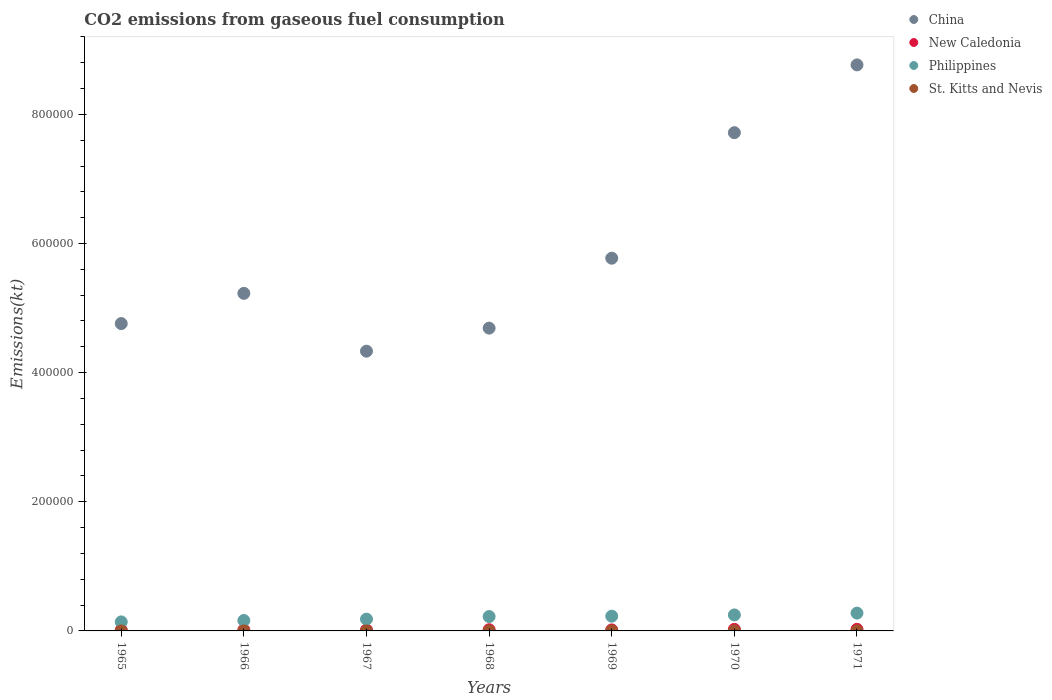Is the number of dotlines equal to the number of legend labels?
Your answer should be compact. Yes. What is the amount of CO2 emitted in China in 1970?
Ensure brevity in your answer.  7.72e+05. Across all years, what is the maximum amount of CO2 emitted in New Caledonia?
Give a very brief answer. 2420.22. Across all years, what is the minimum amount of CO2 emitted in China?
Provide a short and direct response. 4.33e+05. In which year was the amount of CO2 emitted in Philippines maximum?
Your answer should be very brief. 1971. In which year was the amount of CO2 emitted in New Caledonia minimum?
Offer a very short reply. 1965. What is the total amount of CO2 emitted in Philippines in the graph?
Ensure brevity in your answer.  1.46e+05. What is the difference between the amount of CO2 emitted in China in 1966 and that in 1969?
Give a very brief answer. -5.44e+04. What is the difference between the amount of CO2 emitted in China in 1971 and the amount of CO2 emitted in St. Kitts and Nevis in 1970?
Ensure brevity in your answer.  8.77e+05. What is the average amount of CO2 emitted in St. Kitts and Nevis per year?
Offer a terse response. 25.67. In the year 1966, what is the difference between the amount of CO2 emitted in St. Kitts and Nevis and amount of CO2 emitted in New Caledonia?
Give a very brief answer. -1488.8. In how many years, is the amount of CO2 emitted in New Caledonia greater than 640000 kt?
Your answer should be compact. 0. What is the ratio of the amount of CO2 emitted in New Caledonia in 1965 to that in 1969?
Your answer should be very brief. 0.79. What is the difference between the highest and the second highest amount of CO2 emitted in China?
Your answer should be very brief. 1.05e+05. What is the difference between the highest and the lowest amount of CO2 emitted in St. Kitts and Nevis?
Ensure brevity in your answer.  11. Is it the case that in every year, the sum of the amount of CO2 emitted in St. Kitts and Nevis and amount of CO2 emitted in Philippines  is greater than the amount of CO2 emitted in China?
Your answer should be very brief. No. Does the amount of CO2 emitted in New Caledonia monotonically increase over the years?
Make the answer very short. No. Is the amount of CO2 emitted in China strictly greater than the amount of CO2 emitted in Philippines over the years?
Provide a short and direct response. Yes. How many dotlines are there?
Your answer should be compact. 4. How many years are there in the graph?
Your response must be concise. 7. What is the difference between two consecutive major ticks on the Y-axis?
Your response must be concise. 2.00e+05. Are the values on the major ticks of Y-axis written in scientific E-notation?
Offer a terse response. No. Does the graph contain grids?
Keep it short and to the point. No. How many legend labels are there?
Provide a short and direct response. 4. How are the legend labels stacked?
Keep it short and to the point. Vertical. What is the title of the graph?
Your response must be concise. CO2 emissions from gaseous fuel consumption. What is the label or title of the Y-axis?
Ensure brevity in your answer.  Emissions(kt). What is the Emissions(kt) of China in 1965?
Your response must be concise. 4.76e+05. What is the Emissions(kt) of New Caledonia in 1965?
Your answer should be compact. 1232.11. What is the Emissions(kt) of Philippines in 1965?
Give a very brief answer. 1.40e+04. What is the Emissions(kt) of St. Kitts and Nevis in 1965?
Ensure brevity in your answer.  22. What is the Emissions(kt) of China in 1966?
Ensure brevity in your answer.  5.23e+05. What is the Emissions(kt) in New Caledonia in 1966?
Make the answer very short. 1510.8. What is the Emissions(kt) in Philippines in 1966?
Make the answer very short. 1.61e+04. What is the Emissions(kt) in St. Kitts and Nevis in 1966?
Offer a terse response. 22. What is the Emissions(kt) of China in 1967?
Offer a very short reply. 4.33e+05. What is the Emissions(kt) in New Caledonia in 1967?
Keep it short and to the point. 1474.13. What is the Emissions(kt) of Philippines in 1967?
Your answer should be compact. 1.82e+04. What is the Emissions(kt) in St. Kitts and Nevis in 1967?
Provide a short and direct response. 22. What is the Emissions(kt) of China in 1968?
Provide a succinct answer. 4.69e+05. What is the Emissions(kt) of New Caledonia in 1968?
Your answer should be very brief. 1840.83. What is the Emissions(kt) of Philippines in 1968?
Ensure brevity in your answer.  2.23e+04. What is the Emissions(kt) of St. Kitts and Nevis in 1968?
Ensure brevity in your answer.  33. What is the Emissions(kt) in China in 1969?
Make the answer very short. 5.77e+05. What is the Emissions(kt) in New Caledonia in 1969?
Keep it short and to the point. 1558.47. What is the Emissions(kt) of Philippines in 1969?
Ensure brevity in your answer.  2.29e+04. What is the Emissions(kt) in St. Kitts and Nevis in 1969?
Provide a succinct answer. 25.67. What is the Emissions(kt) of China in 1970?
Your answer should be compact. 7.72e+05. What is the Emissions(kt) of New Caledonia in 1970?
Your response must be concise. 2394.55. What is the Emissions(kt) in Philippines in 1970?
Give a very brief answer. 2.48e+04. What is the Emissions(kt) of St. Kitts and Nevis in 1970?
Your answer should be compact. 25.67. What is the Emissions(kt) in China in 1971?
Ensure brevity in your answer.  8.77e+05. What is the Emissions(kt) of New Caledonia in 1971?
Keep it short and to the point. 2420.22. What is the Emissions(kt) in Philippines in 1971?
Your response must be concise. 2.76e+04. What is the Emissions(kt) of St. Kitts and Nevis in 1971?
Your answer should be very brief. 29.34. Across all years, what is the maximum Emissions(kt) in China?
Give a very brief answer. 8.77e+05. Across all years, what is the maximum Emissions(kt) of New Caledonia?
Provide a short and direct response. 2420.22. Across all years, what is the maximum Emissions(kt) in Philippines?
Keep it short and to the point. 2.76e+04. Across all years, what is the maximum Emissions(kt) of St. Kitts and Nevis?
Provide a succinct answer. 33. Across all years, what is the minimum Emissions(kt) of China?
Your response must be concise. 4.33e+05. Across all years, what is the minimum Emissions(kt) in New Caledonia?
Offer a very short reply. 1232.11. Across all years, what is the minimum Emissions(kt) in Philippines?
Your answer should be very brief. 1.40e+04. Across all years, what is the minimum Emissions(kt) in St. Kitts and Nevis?
Give a very brief answer. 22. What is the total Emissions(kt) in China in the graph?
Provide a short and direct response. 4.13e+06. What is the total Emissions(kt) in New Caledonia in the graph?
Your answer should be very brief. 1.24e+04. What is the total Emissions(kt) in Philippines in the graph?
Provide a short and direct response. 1.46e+05. What is the total Emissions(kt) of St. Kitts and Nevis in the graph?
Provide a short and direct response. 179.68. What is the difference between the Emissions(kt) of China in 1965 and that in 1966?
Make the answer very short. -4.68e+04. What is the difference between the Emissions(kt) of New Caledonia in 1965 and that in 1966?
Give a very brief answer. -278.69. What is the difference between the Emissions(kt) of Philippines in 1965 and that in 1966?
Give a very brief answer. -2141.53. What is the difference between the Emissions(kt) of St. Kitts and Nevis in 1965 and that in 1966?
Your response must be concise. 0. What is the difference between the Emissions(kt) of China in 1965 and that in 1967?
Give a very brief answer. 4.27e+04. What is the difference between the Emissions(kt) of New Caledonia in 1965 and that in 1967?
Offer a terse response. -242.02. What is the difference between the Emissions(kt) of Philippines in 1965 and that in 1967?
Your response must be concise. -4250.05. What is the difference between the Emissions(kt) of St. Kitts and Nevis in 1965 and that in 1967?
Provide a short and direct response. 0. What is the difference between the Emissions(kt) in China in 1965 and that in 1968?
Offer a terse response. 7044.31. What is the difference between the Emissions(kt) of New Caledonia in 1965 and that in 1968?
Your answer should be very brief. -608.72. What is the difference between the Emissions(kt) in Philippines in 1965 and that in 1968?
Your answer should be very brief. -8269.08. What is the difference between the Emissions(kt) in St. Kitts and Nevis in 1965 and that in 1968?
Ensure brevity in your answer.  -11. What is the difference between the Emissions(kt) in China in 1965 and that in 1969?
Provide a short and direct response. -1.01e+05. What is the difference between the Emissions(kt) in New Caledonia in 1965 and that in 1969?
Provide a succinct answer. -326.36. What is the difference between the Emissions(kt) of Philippines in 1965 and that in 1969?
Ensure brevity in your answer.  -8877.81. What is the difference between the Emissions(kt) of St. Kitts and Nevis in 1965 and that in 1969?
Offer a very short reply. -3.67. What is the difference between the Emissions(kt) in China in 1965 and that in 1970?
Give a very brief answer. -2.96e+05. What is the difference between the Emissions(kt) of New Caledonia in 1965 and that in 1970?
Keep it short and to the point. -1162.44. What is the difference between the Emissions(kt) in Philippines in 1965 and that in 1970?
Offer a very short reply. -1.08e+04. What is the difference between the Emissions(kt) of St. Kitts and Nevis in 1965 and that in 1970?
Offer a very short reply. -3.67. What is the difference between the Emissions(kt) in China in 1965 and that in 1971?
Make the answer very short. -4.01e+05. What is the difference between the Emissions(kt) in New Caledonia in 1965 and that in 1971?
Your response must be concise. -1188.11. What is the difference between the Emissions(kt) in Philippines in 1965 and that in 1971?
Give a very brief answer. -1.36e+04. What is the difference between the Emissions(kt) in St. Kitts and Nevis in 1965 and that in 1971?
Your response must be concise. -7.33. What is the difference between the Emissions(kt) of China in 1966 and that in 1967?
Offer a terse response. 8.96e+04. What is the difference between the Emissions(kt) of New Caledonia in 1966 and that in 1967?
Give a very brief answer. 36.67. What is the difference between the Emissions(kt) in Philippines in 1966 and that in 1967?
Provide a short and direct response. -2108.53. What is the difference between the Emissions(kt) of China in 1966 and that in 1968?
Offer a terse response. 5.39e+04. What is the difference between the Emissions(kt) of New Caledonia in 1966 and that in 1968?
Provide a succinct answer. -330.03. What is the difference between the Emissions(kt) of Philippines in 1966 and that in 1968?
Offer a very short reply. -6127.56. What is the difference between the Emissions(kt) of St. Kitts and Nevis in 1966 and that in 1968?
Your answer should be compact. -11. What is the difference between the Emissions(kt) in China in 1966 and that in 1969?
Provide a succinct answer. -5.44e+04. What is the difference between the Emissions(kt) in New Caledonia in 1966 and that in 1969?
Keep it short and to the point. -47.67. What is the difference between the Emissions(kt) in Philippines in 1966 and that in 1969?
Provide a short and direct response. -6736.28. What is the difference between the Emissions(kt) of St. Kitts and Nevis in 1966 and that in 1969?
Make the answer very short. -3.67. What is the difference between the Emissions(kt) in China in 1966 and that in 1970?
Provide a succinct answer. -2.49e+05. What is the difference between the Emissions(kt) of New Caledonia in 1966 and that in 1970?
Ensure brevity in your answer.  -883.75. What is the difference between the Emissions(kt) in Philippines in 1966 and that in 1970?
Give a very brief answer. -8657.79. What is the difference between the Emissions(kt) in St. Kitts and Nevis in 1966 and that in 1970?
Keep it short and to the point. -3.67. What is the difference between the Emissions(kt) in China in 1966 and that in 1971?
Your answer should be compact. -3.54e+05. What is the difference between the Emissions(kt) in New Caledonia in 1966 and that in 1971?
Your answer should be very brief. -909.42. What is the difference between the Emissions(kt) of Philippines in 1966 and that in 1971?
Your answer should be compact. -1.15e+04. What is the difference between the Emissions(kt) in St. Kitts and Nevis in 1966 and that in 1971?
Your answer should be very brief. -7.33. What is the difference between the Emissions(kt) of China in 1967 and that in 1968?
Ensure brevity in your answer.  -3.57e+04. What is the difference between the Emissions(kt) in New Caledonia in 1967 and that in 1968?
Offer a very short reply. -366.7. What is the difference between the Emissions(kt) of Philippines in 1967 and that in 1968?
Your response must be concise. -4019.03. What is the difference between the Emissions(kt) in St. Kitts and Nevis in 1967 and that in 1968?
Provide a succinct answer. -11. What is the difference between the Emissions(kt) of China in 1967 and that in 1969?
Give a very brief answer. -1.44e+05. What is the difference between the Emissions(kt) of New Caledonia in 1967 and that in 1969?
Give a very brief answer. -84.34. What is the difference between the Emissions(kt) in Philippines in 1967 and that in 1969?
Make the answer very short. -4627.75. What is the difference between the Emissions(kt) in St. Kitts and Nevis in 1967 and that in 1969?
Give a very brief answer. -3.67. What is the difference between the Emissions(kt) in China in 1967 and that in 1970?
Make the answer very short. -3.38e+05. What is the difference between the Emissions(kt) of New Caledonia in 1967 and that in 1970?
Provide a short and direct response. -920.42. What is the difference between the Emissions(kt) in Philippines in 1967 and that in 1970?
Ensure brevity in your answer.  -6549.26. What is the difference between the Emissions(kt) of St. Kitts and Nevis in 1967 and that in 1970?
Provide a short and direct response. -3.67. What is the difference between the Emissions(kt) of China in 1967 and that in 1971?
Ensure brevity in your answer.  -4.43e+05. What is the difference between the Emissions(kt) in New Caledonia in 1967 and that in 1971?
Your answer should be compact. -946.09. What is the difference between the Emissions(kt) of Philippines in 1967 and that in 1971?
Provide a short and direct response. -9354.52. What is the difference between the Emissions(kt) in St. Kitts and Nevis in 1967 and that in 1971?
Your answer should be compact. -7.33. What is the difference between the Emissions(kt) in China in 1968 and that in 1969?
Offer a very short reply. -1.08e+05. What is the difference between the Emissions(kt) of New Caledonia in 1968 and that in 1969?
Provide a short and direct response. 282.36. What is the difference between the Emissions(kt) in Philippines in 1968 and that in 1969?
Make the answer very short. -608.72. What is the difference between the Emissions(kt) of St. Kitts and Nevis in 1968 and that in 1969?
Your answer should be compact. 7.33. What is the difference between the Emissions(kt) in China in 1968 and that in 1970?
Provide a succinct answer. -3.03e+05. What is the difference between the Emissions(kt) in New Caledonia in 1968 and that in 1970?
Offer a very short reply. -553.72. What is the difference between the Emissions(kt) of Philippines in 1968 and that in 1970?
Give a very brief answer. -2530.23. What is the difference between the Emissions(kt) in St. Kitts and Nevis in 1968 and that in 1970?
Ensure brevity in your answer.  7.33. What is the difference between the Emissions(kt) of China in 1968 and that in 1971?
Keep it short and to the point. -4.08e+05. What is the difference between the Emissions(kt) of New Caledonia in 1968 and that in 1971?
Ensure brevity in your answer.  -579.39. What is the difference between the Emissions(kt) of Philippines in 1968 and that in 1971?
Give a very brief answer. -5335.48. What is the difference between the Emissions(kt) of St. Kitts and Nevis in 1968 and that in 1971?
Provide a succinct answer. 3.67. What is the difference between the Emissions(kt) of China in 1969 and that in 1970?
Give a very brief answer. -1.94e+05. What is the difference between the Emissions(kt) in New Caledonia in 1969 and that in 1970?
Your answer should be very brief. -836.08. What is the difference between the Emissions(kt) in Philippines in 1969 and that in 1970?
Your answer should be very brief. -1921.51. What is the difference between the Emissions(kt) in St. Kitts and Nevis in 1969 and that in 1970?
Your answer should be very brief. 0. What is the difference between the Emissions(kt) in China in 1969 and that in 1971?
Offer a very short reply. -2.99e+05. What is the difference between the Emissions(kt) in New Caledonia in 1969 and that in 1971?
Your answer should be compact. -861.75. What is the difference between the Emissions(kt) of Philippines in 1969 and that in 1971?
Keep it short and to the point. -4726.76. What is the difference between the Emissions(kt) in St. Kitts and Nevis in 1969 and that in 1971?
Provide a short and direct response. -3.67. What is the difference between the Emissions(kt) in China in 1970 and that in 1971?
Offer a very short reply. -1.05e+05. What is the difference between the Emissions(kt) of New Caledonia in 1970 and that in 1971?
Provide a succinct answer. -25.67. What is the difference between the Emissions(kt) of Philippines in 1970 and that in 1971?
Provide a short and direct response. -2805.26. What is the difference between the Emissions(kt) of St. Kitts and Nevis in 1970 and that in 1971?
Make the answer very short. -3.67. What is the difference between the Emissions(kt) in China in 1965 and the Emissions(kt) in New Caledonia in 1966?
Ensure brevity in your answer.  4.74e+05. What is the difference between the Emissions(kt) of China in 1965 and the Emissions(kt) of Philippines in 1966?
Your answer should be compact. 4.60e+05. What is the difference between the Emissions(kt) in China in 1965 and the Emissions(kt) in St. Kitts and Nevis in 1966?
Provide a short and direct response. 4.76e+05. What is the difference between the Emissions(kt) of New Caledonia in 1965 and the Emissions(kt) of Philippines in 1966?
Your response must be concise. -1.49e+04. What is the difference between the Emissions(kt) in New Caledonia in 1965 and the Emissions(kt) in St. Kitts and Nevis in 1966?
Ensure brevity in your answer.  1210.11. What is the difference between the Emissions(kt) in Philippines in 1965 and the Emissions(kt) in St. Kitts and Nevis in 1966?
Give a very brief answer. 1.40e+04. What is the difference between the Emissions(kt) of China in 1965 and the Emissions(kt) of New Caledonia in 1967?
Your answer should be compact. 4.74e+05. What is the difference between the Emissions(kt) in China in 1965 and the Emissions(kt) in Philippines in 1967?
Give a very brief answer. 4.58e+05. What is the difference between the Emissions(kt) of China in 1965 and the Emissions(kt) of St. Kitts and Nevis in 1967?
Your response must be concise. 4.76e+05. What is the difference between the Emissions(kt) of New Caledonia in 1965 and the Emissions(kt) of Philippines in 1967?
Your answer should be compact. -1.70e+04. What is the difference between the Emissions(kt) of New Caledonia in 1965 and the Emissions(kt) of St. Kitts and Nevis in 1967?
Offer a terse response. 1210.11. What is the difference between the Emissions(kt) of Philippines in 1965 and the Emissions(kt) of St. Kitts and Nevis in 1967?
Offer a terse response. 1.40e+04. What is the difference between the Emissions(kt) in China in 1965 and the Emissions(kt) in New Caledonia in 1968?
Make the answer very short. 4.74e+05. What is the difference between the Emissions(kt) of China in 1965 and the Emissions(kt) of Philippines in 1968?
Your answer should be compact. 4.54e+05. What is the difference between the Emissions(kt) in China in 1965 and the Emissions(kt) in St. Kitts and Nevis in 1968?
Your response must be concise. 4.76e+05. What is the difference between the Emissions(kt) of New Caledonia in 1965 and the Emissions(kt) of Philippines in 1968?
Offer a terse response. -2.10e+04. What is the difference between the Emissions(kt) in New Caledonia in 1965 and the Emissions(kt) in St. Kitts and Nevis in 1968?
Offer a very short reply. 1199.11. What is the difference between the Emissions(kt) in Philippines in 1965 and the Emissions(kt) in St. Kitts and Nevis in 1968?
Offer a terse response. 1.39e+04. What is the difference between the Emissions(kt) in China in 1965 and the Emissions(kt) in New Caledonia in 1969?
Your answer should be very brief. 4.74e+05. What is the difference between the Emissions(kt) of China in 1965 and the Emissions(kt) of Philippines in 1969?
Your response must be concise. 4.53e+05. What is the difference between the Emissions(kt) of China in 1965 and the Emissions(kt) of St. Kitts and Nevis in 1969?
Offer a terse response. 4.76e+05. What is the difference between the Emissions(kt) of New Caledonia in 1965 and the Emissions(kt) of Philippines in 1969?
Your answer should be very brief. -2.16e+04. What is the difference between the Emissions(kt) of New Caledonia in 1965 and the Emissions(kt) of St. Kitts and Nevis in 1969?
Provide a short and direct response. 1206.44. What is the difference between the Emissions(kt) of Philippines in 1965 and the Emissions(kt) of St. Kitts and Nevis in 1969?
Your response must be concise. 1.40e+04. What is the difference between the Emissions(kt) in China in 1965 and the Emissions(kt) in New Caledonia in 1970?
Give a very brief answer. 4.74e+05. What is the difference between the Emissions(kt) of China in 1965 and the Emissions(kt) of Philippines in 1970?
Make the answer very short. 4.51e+05. What is the difference between the Emissions(kt) of China in 1965 and the Emissions(kt) of St. Kitts and Nevis in 1970?
Your response must be concise. 4.76e+05. What is the difference between the Emissions(kt) in New Caledonia in 1965 and the Emissions(kt) in Philippines in 1970?
Make the answer very short. -2.35e+04. What is the difference between the Emissions(kt) of New Caledonia in 1965 and the Emissions(kt) of St. Kitts and Nevis in 1970?
Your answer should be very brief. 1206.44. What is the difference between the Emissions(kt) of Philippines in 1965 and the Emissions(kt) of St. Kitts and Nevis in 1970?
Your response must be concise. 1.40e+04. What is the difference between the Emissions(kt) of China in 1965 and the Emissions(kt) of New Caledonia in 1971?
Your response must be concise. 4.74e+05. What is the difference between the Emissions(kt) in China in 1965 and the Emissions(kt) in Philippines in 1971?
Ensure brevity in your answer.  4.48e+05. What is the difference between the Emissions(kt) in China in 1965 and the Emissions(kt) in St. Kitts and Nevis in 1971?
Provide a succinct answer. 4.76e+05. What is the difference between the Emissions(kt) of New Caledonia in 1965 and the Emissions(kt) of Philippines in 1971?
Your response must be concise. -2.64e+04. What is the difference between the Emissions(kt) in New Caledonia in 1965 and the Emissions(kt) in St. Kitts and Nevis in 1971?
Keep it short and to the point. 1202.78. What is the difference between the Emissions(kt) in Philippines in 1965 and the Emissions(kt) in St. Kitts and Nevis in 1971?
Ensure brevity in your answer.  1.40e+04. What is the difference between the Emissions(kt) in China in 1966 and the Emissions(kt) in New Caledonia in 1967?
Your answer should be compact. 5.21e+05. What is the difference between the Emissions(kt) in China in 1966 and the Emissions(kt) in Philippines in 1967?
Ensure brevity in your answer.  5.05e+05. What is the difference between the Emissions(kt) of China in 1966 and the Emissions(kt) of St. Kitts and Nevis in 1967?
Your answer should be compact. 5.23e+05. What is the difference between the Emissions(kt) in New Caledonia in 1966 and the Emissions(kt) in Philippines in 1967?
Make the answer very short. -1.67e+04. What is the difference between the Emissions(kt) of New Caledonia in 1966 and the Emissions(kt) of St. Kitts and Nevis in 1967?
Offer a terse response. 1488.8. What is the difference between the Emissions(kt) in Philippines in 1966 and the Emissions(kt) in St. Kitts and Nevis in 1967?
Your response must be concise. 1.61e+04. What is the difference between the Emissions(kt) of China in 1966 and the Emissions(kt) of New Caledonia in 1968?
Make the answer very short. 5.21e+05. What is the difference between the Emissions(kt) of China in 1966 and the Emissions(kt) of Philippines in 1968?
Provide a short and direct response. 5.01e+05. What is the difference between the Emissions(kt) in China in 1966 and the Emissions(kt) in St. Kitts and Nevis in 1968?
Offer a very short reply. 5.23e+05. What is the difference between the Emissions(kt) in New Caledonia in 1966 and the Emissions(kt) in Philippines in 1968?
Your answer should be compact. -2.07e+04. What is the difference between the Emissions(kt) of New Caledonia in 1966 and the Emissions(kt) of St. Kitts and Nevis in 1968?
Your response must be concise. 1477.8. What is the difference between the Emissions(kt) of Philippines in 1966 and the Emissions(kt) of St. Kitts and Nevis in 1968?
Give a very brief answer. 1.61e+04. What is the difference between the Emissions(kt) of China in 1966 and the Emissions(kt) of New Caledonia in 1969?
Provide a succinct answer. 5.21e+05. What is the difference between the Emissions(kt) in China in 1966 and the Emissions(kt) in Philippines in 1969?
Offer a very short reply. 5.00e+05. What is the difference between the Emissions(kt) in China in 1966 and the Emissions(kt) in St. Kitts and Nevis in 1969?
Offer a very short reply. 5.23e+05. What is the difference between the Emissions(kt) in New Caledonia in 1966 and the Emissions(kt) in Philippines in 1969?
Offer a terse response. -2.13e+04. What is the difference between the Emissions(kt) in New Caledonia in 1966 and the Emissions(kt) in St. Kitts and Nevis in 1969?
Provide a short and direct response. 1485.13. What is the difference between the Emissions(kt) of Philippines in 1966 and the Emissions(kt) of St. Kitts and Nevis in 1969?
Your answer should be compact. 1.61e+04. What is the difference between the Emissions(kt) of China in 1966 and the Emissions(kt) of New Caledonia in 1970?
Ensure brevity in your answer.  5.20e+05. What is the difference between the Emissions(kt) in China in 1966 and the Emissions(kt) in Philippines in 1970?
Ensure brevity in your answer.  4.98e+05. What is the difference between the Emissions(kt) in China in 1966 and the Emissions(kt) in St. Kitts and Nevis in 1970?
Provide a succinct answer. 5.23e+05. What is the difference between the Emissions(kt) of New Caledonia in 1966 and the Emissions(kt) of Philippines in 1970?
Give a very brief answer. -2.33e+04. What is the difference between the Emissions(kt) in New Caledonia in 1966 and the Emissions(kt) in St. Kitts and Nevis in 1970?
Your answer should be very brief. 1485.13. What is the difference between the Emissions(kt) in Philippines in 1966 and the Emissions(kt) in St. Kitts and Nevis in 1970?
Offer a terse response. 1.61e+04. What is the difference between the Emissions(kt) in China in 1966 and the Emissions(kt) in New Caledonia in 1971?
Keep it short and to the point. 5.20e+05. What is the difference between the Emissions(kt) in China in 1966 and the Emissions(kt) in Philippines in 1971?
Give a very brief answer. 4.95e+05. What is the difference between the Emissions(kt) of China in 1966 and the Emissions(kt) of St. Kitts and Nevis in 1971?
Give a very brief answer. 5.23e+05. What is the difference between the Emissions(kt) of New Caledonia in 1966 and the Emissions(kt) of Philippines in 1971?
Ensure brevity in your answer.  -2.61e+04. What is the difference between the Emissions(kt) of New Caledonia in 1966 and the Emissions(kt) of St. Kitts and Nevis in 1971?
Your answer should be very brief. 1481.47. What is the difference between the Emissions(kt) of Philippines in 1966 and the Emissions(kt) of St. Kitts and Nevis in 1971?
Provide a succinct answer. 1.61e+04. What is the difference between the Emissions(kt) of China in 1967 and the Emissions(kt) of New Caledonia in 1968?
Ensure brevity in your answer.  4.31e+05. What is the difference between the Emissions(kt) of China in 1967 and the Emissions(kt) of Philippines in 1968?
Offer a very short reply. 4.11e+05. What is the difference between the Emissions(kt) of China in 1967 and the Emissions(kt) of St. Kitts and Nevis in 1968?
Give a very brief answer. 4.33e+05. What is the difference between the Emissions(kt) of New Caledonia in 1967 and the Emissions(kt) of Philippines in 1968?
Your answer should be very brief. -2.08e+04. What is the difference between the Emissions(kt) of New Caledonia in 1967 and the Emissions(kt) of St. Kitts and Nevis in 1968?
Keep it short and to the point. 1441.13. What is the difference between the Emissions(kt) of Philippines in 1967 and the Emissions(kt) of St. Kitts and Nevis in 1968?
Your response must be concise. 1.82e+04. What is the difference between the Emissions(kt) in China in 1967 and the Emissions(kt) in New Caledonia in 1969?
Your response must be concise. 4.32e+05. What is the difference between the Emissions(kt) in China in 1967 and the Emissions(kt) in Philippines in 1969?
Ensure brevity in your answer.  4.10e+05. What is the difference between the Emissions(kt) in China in 1967 and the Emissions(kt) in St. Kitts and Nevis in 1969?
Your answer should be very brief. 4.33e+05. What is the difference between the Emissions(kt) in New Caledonia in 1967 and the Emissions(kt) in Philippines in 1969?
Your answer should be very brief. -2.14e+04. What is the difference between the Emissions(kt) in New Caledonia in 1967 and the Emissions(kt) in St. Kitts and Nevis in 1969?
Ensure brevity in your answer.  1448.46. What is the difference between the Emissions(kt) in Philippines in 1967 and the Emissions(kt) in St. Kitts and Nevis in 1969?
Make the answer very short. 1.82e+04. What is the difference between the Emissions(kt) in China in 1967 and the Emissions(kt) in New Caledonia in 1970?
Your answer should be very brief. 4.31e+05. What is the difference between the Emissions(kt) of China in 1967 and the Emissions(kt) of Philippines in 1970?
Your answer should be compact. 4.08e+05. What is the difference between the Emissions(kt) of China in 1967 and the Emissions(kt) of St. Kitts and Nevis in 1970?
Keep it short and to the point. 4.33e+05. What is the difference between the Emissions(kt) of New Caledonia in 1967 and the Emissions(kt) of Philippines in 1970?
Provide a short and direct response. -2.33e+04. What is the difference between the Emissions(kt) of New Caledonia in 1967 and the Emissions(kt) of St. Kitts and Nevis in 1970?
Make the answer very short. 1448.46. What is the difference between the Emissions(kt) in Philippines in 1967 and the Emissions(kt) in St. Kitts and Nevis in 1970?
Your answer should be very brief. 1.82e+04. What is the difference between the Emissions(kt) of China in 1967 and the Emissions(kt) of New Caledonia in 1971?
Keep it short and to the point. 4.31e+05. What is the difference between the Emissions(kt) in China in 1967 and the Emissions(kt) in Philippines in 1971?
Give a very brief answer. 4.06e+05. What is the difference between the Emissions(kt) of China in 1967 and the Emissions(kt) of St. Kitts and Nevis in 1971?
Keep it short and to the point. 4.33e+05. What is the difference between the Emissions(kt) of New Caledonia in 1967 and the Emissions(kt) of Philippines in 1971?
Your answer should be very brief. -2.61e+04. What is the difference between the Emissions(kt) of New Caledonia in 1967 and the Emissions(kt) of St. Kitts and Nevis in 1971?
Your answer should be very brief. 1444.8. What is the difference between the Emissions(kt) of Philippines in 1967 and the Emissions(kt) of St. Kitts and Nevis in 1971?
Keep it short and to the point. 1.82e+04. What is the difference between the Emissions(kt) in China in 1968 and the Emissions(kt) in New Caledonia in 1969?
Your answer should be compact. 4.67e+05. What is the difference between the Emissions(kt) in China in 1968 and the Emissions(kt) in Philippines in 1969?
Your response must be concise. 4.46e+05. What is the difference between the Emissions(kt) of China in 1968 and the Emissions(kt) of St. Kitts and Nevis in 1969?
Ensure brevity in your answer.  4.69e+05. What is the difference between the Emissions(kt) in New Caledonia in 1968 and the Emissions(kt) in Philippines in 1969?
Provide a short and direct response. -2.10e+04. What is the difference between the Emissions(kt) of New Caledonia in 1968 and the Emissions(kt) of St. Kitts and Nevis in 1969?
Your response must be concise. 1815.16. What is the difference between the Emissions(kt) in Philippines in 1968 and the Emissions(kt) in St. Kitts and Nevis in 1969?
Offer a terse response. 2.22e+04. What is the difference between the Emissions(kt) in China in 1968 and the Emissions(kt) in New Caledonia in 1970?
Keep it short and to the point. 4.67e+05. What is the difference between the Emissions(kt) of China in 1968 and the Emissions(kt) of Philippines in 1970?
Your answer should be compact. 4.44e+05. What is the difference between the Emissions(kt) of China in 1968 and the Emissions(kt) of St. Kitts and Nevis in 1970?
Provide a succinct answer. 4.69e+05. What is the difference between the Emissions(kt) of New Caledonia in 1968 and the Emissions(kt) of Philippines in 1970?
Your response must be concise. -2.29e+04. What is the difference between the Emissions(kt) of New Caledonia in 1968 and the Emissions(kt) of St. Kitts and Nevis in 1970?
Provide a succinct answer. 1815.16. What is the difference between the Emissions(kt) in Philippines in 1968 and the Emissions(kt) in St. Kitts and Nevis in 1970?
Your answer should be very brief. 2.22e+04. What is the difference between the Emissions(kt) in China in 1968 and the Emissions(kt) in New Caledonia in 1971?
Offer a very short reply. 4.67e+05. What is the difference between the Emissions(kt) in China in 1968 and the Emissions(kt) in Philippines in 1971?
Your answer should be compact. 4.41e+05. What is the difference between the Emissions(kt) of China in 1968 and the Emissions(kt) of St. Kitts and Nevis in 1971?
Your answer should be compact. 4.69e+05. What is the difference between the Emissions(kt) of New Caledonia in 1968 and the Emissions(kt) of Philippines in 1971?
Ensure brevity in your answer.  -2.57e+04. What is the difference between the Emissions(kt) in New Caledonia in 1968 and the Emissions(kt) in St. Kitts and Nevis in 1971?
Your answer should be compact. 1811.5. What is the difference between the Emissions(kt) in Philippines in 1968 and the Emissions(kt) in St. Kitts and Nevis in 1971?
Make the answer very short. 2.22e+04. What is the difference between the Emissions(kt) of China in 1969 and the Emissions(kt) of New Caledonia in 1970?
Your answer should be compact. 5.75e+05. What is the difference between the Emissions(kt) of China in 1969 and the Emissions(kt) of Philippines in 1970?
Your answer should be very brief. 5.52e+05. What is the difference between the Emissions(kt) in China in 1969 and the Emissions(kt) in St. Kitts and Nevis in 1970?
Provide a succinct answer. 5.77e+05. What is the difference between the Emissions(kt) in New Caledonia in 1969 and the Emissions(kt) in Philippines in 1970?
Make the answer very short. -2.32e+04. What is the difference between the Emissions(kt) of New Caledonia in 1969 and the Emissions(kt) of St. Kitts and Nevis in 1970?
Keep it short and to the point. 1532.81. What is the difference between the Emissions(kt) in Philippines in 1969 and the Emissions(kt) in St. Kitts and Nevis in 1970?
Make the answer very short. 2.28e+04. What is the difference between the Emissions(kt) in China in 1969 and the Emissions(kt) in New Caledonia in 1971?
Your answer should be very brief. 5.75e+05. What is the difference between the Emissions(kt) in China in 1969 and the Emissions(kt) in Philippines in 1971?
Ensure brevity in your answer.  5.50e+05. What is the difference between the Emissions(kt) in China in 1969 and the Emissions(kt) in St. Kitts and Nevis in 1971?
Provide a succinct answer. 5.77e+05. What is the difference between the Emissions(kt) in New Caledonia in 1969 and the Emissions(kt) in Philippines in 1971?
Keep it short and to the point. -2.60e+04. What is the difference between the Emissions(kt) in New Caledonia in 1969 and the Emissions(kt) in St. Kitts and Nevis in 1971?
Offer a very short reply. 1529.14. What is the difference between the Emissions(kt) of Philippines in 1969 and the Emissions(kt) of St. Kitts and Nevis in 1971?
Make the answer very short. 2.28e+04. What is the difference between the Emissions(kt) in China in 1970 and the Emissions(kt) in New Caledonia in 1971?
Your answer should be compact. 7.69e+05. What is the difference between the Emissions(kt) in China in 1970 and the Emissions(kt) in Philippines in 1971?
Provide a short and direct response. 7.44e+05. What is the difference between the Emissions(kt) in China in 1970 and the Emissions(kt) in St. Kitts and Nevis in 1971?
Make the answer very short. 7.72e+05. What is the difference between the Emissions(kt) in New Caledonia in 1970 and the Emissions(kt) in Philippines in 1971?
Ensure brevity in your answer.  -2.52e+04. What is the difference between the Emissions(kt) of New Caledonia in 1970 and the Emissions(kt) of St. Kitts and Nevis in 1971?
Provide a succinct answer. 2365.22. What is the difference between the Emissions(kt) in Philippines in 1970 and the Emissions(kt) in St. Kitts and Nevis in 1971?
Your response must be concise. 2.48e+04. What is the average Emissions(kt) of China per year?
Keep it short and to the point. 5.89e+05. What is the average Emissions(kt) of New Caledonia per year?
Keep it short and to the point. 1775.88. What is the average Emissions(kt) in Philippines per year?
Ensure brevity in your answer.  2.08e+04. What is the average Emissions(kt) of St. Kitts and Nevis per year?
Provide a succinct answer. 25.67. In the year 1965, what is the difference between the Emissions(kt) of China and Emissions(kt) of New Caledonia?
Give a very brief answer. 4.75e+05. In the year 1965, what is the difference between the Emissions(kt) of China and Emissions(kt) of Philippines?
Offer a very short reply. 4.62e+05. In the year 1965, what is the difference between the Emissions(kt) of China and Emissions(kt) of St. Kitts and Nevis?
Offer a terse response. 4.76e+05. In the year 1965, what is the difference between the Emissions(kt) of New Caledonia and Emissions(kt) of Philippines?
Your answer should be very brief. -1.28e+04. In the year 1965, what is the difference between the Emissions(kt) in New Caledonia and Emissions(kt) in St. Kitts and Nevis?
Your answer should be very brief. 1210.11. In the year 1965, what is the difference between the Emissions(kt) of Philippines and Emissions(kt) of St. Kitts and Nevis?
Offer a very short reply. 1.40e+04. In the year 1966, what is the difference between the Emissions(kt) of China and Emissions(kt) of New Caledonia?
Your answer should be compact. 5.21e+05. In the year 1966, what is the difference between the Emissions(kt) in China and Emissions(kt) in Philippines?
Provide a succinct answer. 5.07e+05. In the year 1966, what is the difference between the Emissions(kt) in China and Emissions(kt) in St. Kitts and Nevis?
Offer a terse response. 5.23e+05. In the year 1966, what is the difference between the Emissions(kt) of New Caledonia and Emissions(kt) of Philippines?
Offer a very short reply. -1.46e+04. In the year 1966, what is the difference between the Emissions(kt) in New Caledonia and Emissions(kt) in St. Kitts and Nevis?
Provide a succinct answer. 1488.8. In the year 1966, what is the difference between the Emissions(kt) of Philippines and Emissions(kt) of St. Kitts and Nevis?
Ensure brevity in your answer.  1.61e+04. In the year 1967, what is the difference between the Emissions(kt) in China and Emissions(kt) in New Caledonia?
Make the answer very short. 4.32e+05. In the year 1967, what is the difference between the Emissions(kt) of China and Emissions(kt) of Philippines?
Offer a terse response. 4.15e+05. In the year 1967, what is the difference between the Emissions(kt) in China and Emissions(kt) in St. Kitts and Nevis?
Keep it short and to the point. 4.33e+05. In the year 1967, what is the difference between the Emissions(kt) of New Caledonia and Emissions(kt) of Philippines?
Your answer should be very brief. -1.68e+04. In the year 1967, what is the difference between the Emissions(kt) in New Caledonia and Emissions(kt) in St. Kitts and Nevis?
Keep it short and to the point. 1452.13. In the year 1967, what is the difference between the Emissions(kt) of Philippines and Emissions(kt) of St. Kitts and Nevis?
Provide a short and direct response. 1.82e+04. In the year 1968, what is the difference between the Emissions(kt) of China and Emissions(kt) of New Caledonia?
Keep it short and to the point. 4.67e+05. In the year 1968, what is the difference between the Emissions(kt) of China and Emissions(kt) of Philippines?
Your response must be concise. 4.47e+05. In the year 1968, what is the difference between the Emissions(kt) of China and Emissions(kt) of St. Kitts and Nevis?
Provide a succinct answer. 4.69e+05. In the year 1968, what is the difference between the Emissions(kt) of New Caledonia and Emissions(kt) of Philippines?
Give a very brief answer. -2.04e+04. In the year 1968, what is the difference between the Emissions(kt) of New Caledonia and Emissions(kt) of St. Kitts and Nevis?
Give a very brief answer. 1807.83. In the year 1968, what is the difference between the Emissions(kt) in Philippines and Emissions(kt) in St. Kitts and Nevis?
Provide a succinct answer. 2.22e+04. In the year 1969, what is the difference between the Emissions(kt) of China and Emissions(kt) of New Caledonia?
Ensure brevity in your answer.  5.76e+05. In the year 1969, what is the difference between the Emissions(kt) in China and Emissions(kt) in Philippines?
Offer a terse response. 5.54e+05. In the year 1969, what is the difference between the Emissions(kt) of China and Emissions(kt) of St. Kitts and Nevis?
Provide a short and direct response. 5.77e+05. In the year 1969, what is the difference between the Emissions(kt) of New Caledonia and Emissions(kt) of Philippines?
Your answer should be compact. -2.13e+04. In the year 1969, what is the difference between the Emissions(kt) in New Caledonia and Emissions(kt) in St. Kitts and Nevis?
Offer a terse response. 1532.81. In the year 1969, what is the difference between the Emissions(kt) in Philippines and Emissions(kt) in St. Kitts and Nevis?
Give a very brief answer. 2.28e+04. In the year 1970, what is the difference between the Emissions(kt) of China and Emissions(kt) of New Caledonia?
Keep it short and to the point. 7.69e+05. In the year 1970, what is the difference between the Emissions(kt) in China and Emissions(kt) in Philippines?
Make the answer very short. 7.47e+05. In the year 1970, what is the difference between the Emissions(kt) in China and Emissions(kt) in St. Kitts and Nevis?
Offer a terse response. 7.72e+05. In the year 1970, what is the difference between the Emissions(kt) of New Caledonia and Emissions(kt) of Philippines?
Ensure brevity in your answer.  -2.24e+04. In the year 1970, what is the difference between the Emissions(kt) in New Caledonia and Emissions(kt) in St. Kitts and Nevis?
Keep it short and to the point. 2368.88. In the year 1970, what is the difference between the Emissions(kt) of Philippines and Emissions(kt) of St. Kitts and Nevis?
Ensure brevity in your answer.  2.48e+04. In the year 1971, what is the difference between the Emissions(kt) in China and Emissions(kt) in New Caledonia?
Provide a succinct answer. 8.74e+05. In the year 1971, what is the difference between the Emissions(kt) in China and Emissions(kt) in Philippines?
Make the answer very short. 8.49e+05. In the year 1971, what is the difference between the Emissions(kt) in China and Emissions(kt) in St. Kitts and Nevis?
Provide a succinct answer. 8.77e+05. In the year 1971, what is the difference between the Emissions(kt) in New Caledonia and Emissions(kt) in Philippines?
Your answer should be compact. -2.52e+04. In the year 1971, what is the difference between the Emissions(kt) of New Caledonia and Emissions(kt) of St. Kitts and Nevis?
Offer a very short reply. 2390.88. In the year 1971, what is the difference between the Emissions(kt) of Philippines and Emissions(kt) of St. Kitts and Nevis?
Give a very brief answer. 2.76e+04. What is the ratio of the Emissions(kt) in China in 1965 to that in 1966?
Provide a succinct answer. 0.91. What is the ratio of the Emissions(kt) of New Caledonia in 1965 to that in 1966?
Ensure brevity in your answer.  0.82. What is the ratio of the Emissions(kt) in Philippines in 1965 to that in 1966?
Give a very brief answer. 0.87. What is the ratio of the Emissions(kt) of China in 1965 to that in 1967?
Provide a succinct answer. 1.1. What is the ratio of the Emissions(kt) of New Caledonia in 1965 to that in 1967?
Offer a very short reply. 0.84. What is the ratio of the Emissions(kt) of Philippines in 1965 to that in 1967?
Your answer should be compact. 0.77. What is the ratio of the Emissions(kt) of St. Kitts and Nevis in 1965 to that in 1967?
Give a very brief answer. 1. What is the ratio of the Emissions(kt) in China in 1965 to that in 1968?
Provide a short and direct response. 1.01. What is the ratio of the Emissions(kt) in New Caledonia in 1965 to that in 1968?
Provide a succinct answer. 0.67. What is the ratio of the Emissions(kt) of Philippines in 1965 to that in 1968?
Your answer should be very brief. 0.63. What is the ratio of the Emissions(kt) of St. Kitts and Nevis in 1965 to that in 1968?
Keep it short and to the point. 0.67. What is the ratio of the Emissions(kt) in China in 1965 to that in 1969?
Keep it short and to the point. 0.82. What is the ratio of the Emissions(kt) of New Caledonia in 1965 to that in 1969?
Provide a succinct answer. 0.79. What is the ratio of the Emissions(kt) in Philippines in 1965 to that in 1969?
Keep it short and to the point. 0.61. What is the ratio of the Emissions(kt) in China in 1965 to that in 1970?
Offer a very short reply. 0.62. What is the ratio of the Emissions(kt) in New Caledonia in 1965 to that in 1970?
Keep it short and to the point. 0.51. What is the ratio of the Emissions(kt) of Philippines in 1965 to that in 1970?
Offer a terse response. 0.56. What is the ratio of the Emissions(kt) in St. Kitts and Nevis in 1965 to that in 1970?
Offer a terse response. 0.86. What is the ratio of the Emissions(kt) in China in 1965 to that in 1971?
Ensure brevity in your answer.  0.54. What is the ratio of the Emissions(kt) of New Caledonia in 1965 to that in 1971?
Ensure brevity in your answer.  0.51. What is the ratio of the Emissions(kt) of Philippines in 1965 to that in 1971?
Offer a terse response. 0.51. What is the ratio of the Emissions(kt) in China in 1966 to that in 1967?
Give a very brief answer. 1.21. What is the ratio of the Emissions(kt) of New Caledonia in 1966 to that in 1967?
Make the answer very short. 1.02. What is the ratio of the Emissions(kt) in Philippines in 1966 to that in 1967?
Keep it short and to the point. 0.88. What is the ratio of the Emissions(kt) of China in 1966 to that in 1968?
Provide a short and direct response. 1.11. What is the ratio of the Emissions(kt) in New Caledonia in 1966 to that in 1968?
Make the answer very short. 0.82. What is the ratio of the Emissions(kt) in Philippines in 1966 to that in 1968?
Ensure brevity in your answer.  0.72. What is the ratio of the Emissions(kt) in China in 1966 to that in 1969?
Your answer should be compact. 0.91. What is the ratio of the Emissions(kt) in New Caledonia in 1966 to that in 1969?
Offer a very short reply. 0.97. What is the ratio of the Emissions(kt) of Philippines in 1966 to that in 1969?
Make the answer very short. 0.71. What is the ratio of the Emissions(kt) in St. Kitts and Nevis in 1966 to that in 1969?
Offer a very short reply. 0.86. What is the ratio of the Emissions(kt) of China in 1966 to that in 1970?
Your response must be concise. 0.68. What is the ratio of the Emissions(kt) in New Caledonia in 1966 to that in 1970?
Provide a short and direct response. 0.63. What is the ratio of the Emissions(kt) in Philippines in 1966 to that in 1970?
Keep it short and to the point. 0.65. What is the ratio of the Emissions(kt) in China in 1966 to that in 1971?
Provide a succinct answer. 0.6. What is the ratio of the Emissions(kt) of New Caledonia in 1966 to that in 1971?
Offer a very short reply. 0.62. What is the ratio of the Emissions(kt) in Philippines in 1966 to that in 1971?
Provide a short and direct response. 0.58. What is the ratio of the Emissions(kt) in China in 1967 to that in 1968?
Provide a short and direct response. 0.92. What is the ratio of the Emissions(kt) of New Caledonia in 1967 to that in 1968?
Keep it short and to the point. 0.8. What is the ratio of the Emissions(kt) in Philippines in 1967 to that in 1968?
Provide a succinct answer. 0.82. What is the ratio of the Emissions(kt) in St. Kitts and Nevis in 1967 to that in 1968?
Give a very brief answer. 0.67. What is the ratio of the Emissions(kt) of China in 1967 to that in 1969?
Keep it short and to the point. 0.75. What is the ratio of the Emissions(kt) of New Caledonia in 1967 to that in 1969?
Ensure brevity in your answer.  0.95. What is the ratio of the Emissions(kt) in Philippines in 1967 to that in 1969?
Offer a terse response. 0.8. What is the ratio of the Emissions(kt) in China in 1967 to that in 1970?
Provide a succinct answer. 0.56. What is the ratio of the Emissions(kt) of New Caledonia in 1967 to that in 1970?
Offer a terse response. 0.62. What is the ratio of the Emissions(kt) in Philippines in 1967 to that in 1970?
Give a very brief answer. 0.74. What is the ratio of the Emissions(kt) of St. Kitts and Nevis in 1967 to that in 1970?
Offer a very short reply. 0.86. What is the ratio of the Emissions(kt) of China in 1967 to that in 1971?
Provide a short and direct response. 0.49. What is the ratio of the Emissions(kt) of New Caledonia in 1967 to that in 1971?
Give a very brief answer. 0.61. What is the ratio of the Emissions(kt) in Philippines in 1967 to that in 1971?
Ensure brevity in your answer.  0.66. What is the ratio of the Emissions(kt) of St. Kitts and Nevis in 1967 to that in 1971?
Offer a terse response. 0.75. What is the ratio of the Emissions(kt) of China in 1968 to that in 1969?
Keep it short and to the point. 0.81. What is the ratio of the Emissions(kt) in New Caledonia in 1968 to that in 1969?
Make the answer very short. 1.18. What is the ratio of the Emissions(kt) in Philippines in 1968 to that in 1969?
Provide a succinct answer. 0.97. What is the ratio of the Emissions(kt) of St. Kitts and Nevis in 1968 to that in 1969?
Provide a short and direct response. 1.29. What is the ratio of the Emissions(kt) of China in 1968 to that in 1970?
Your answer should be compact. 0.61. What is the ratio of the Emissions(kt) in New Caledonia in 1968 to that in 1970?
Provide a succinct answer. 0.77. What is the ratio of the Emissions(kt) in Philippines in 1968 to that in 1970?
Ensure brevity in your answer.  0.9. What is the ratio of the Emissions(kt) in China in 1968 to that in 1971?
Ensure brevity in your answer.  0.53. What is the ratio of the Emissions(kt) in New Caledonia in 1968 to that in 1971?
Provide a succinct answer. 0.76. What is the ratio of the Emissions(kt) of Philippines in 1968 to that in 1971?
Your answer should be compact. 0.81. What is the ratio of the Emissions(kt) in St. Kitts and Nevis in 1968 to that in 1971?
Provide a succinct answer. 1.12. What is the ratio of the Emissions(kt) of China in 1969 to that in 1970?
Keep it short and to the point. 0.75. What is the ratio of the Emissions(kt) of New Caledonia in 1969 to that in 1970?
Offer a very short reply. 0.65. What is the ratio of the Emissions(kt) of Philippines in 1969 to that in 1970?
Offer a very short reply. 0.92. What is the ratio of the Emissions(kt) in China in 1969 to that in 1971?
Make the answer very short. 0.66. What is the ratio of the Emissions(kt) of New Caledonia in 1969 to that in 1971?
Provide a succinct answer. 0.64. What is the ratio of the Emissions(kt) in Philippines in 1969 to that in 1971?
Provide a succinct answer. 0.83. What is the ratio of the Emissions(kt) in St. Kitts and Nevis in 1969 to that in 1971?
Keep it short and to the point. 0.88. What is the ratio of the Emissions(kt) in China in 1970 to that in 1971?
Your answer should be very brief. 0.88. What is the ratio of the Emissions(kt) in New Caledonia in 1970 to that in 1971?
Give a very brief answer. 0.99. What is the ratio of the Emissions(kt) in Philippines in 1970 to that in 1971?
Your answer should be compact. 0.9. What is the difference between the highest and the second highest Emissions(kt) of China?
Provide a succinct answer. 1.05e+05. What is the difference between the highest and the second highest Emissions(kt) of New Caledonia?
Offer a terse response. 25.67. What is the difference between the highest and the second highest Emissions(kt) of Philippines?
Offer a very short reply. 2805.26. What is the difference between the highest and the second highest Emissions(kt) in St. Kitts and Nevis?
Provide a succinct answer. 3.67. What is the difference between the highest and the lowest Emissions(kt) of China?
Keep it short and to the point. 4.43e+05. What is the difference between the highest and the lowest Emissions(kt) of New Caledonia?
Provide a short and direct response. 1188.11. What is the difference between the highest and the lowest Emissions(kt) in Philippines?
Your answer should be very brief. 1.36e+04. What is the difference between the highest and the lowest Emissions(kt) in St. Kitts and Nevis?
Give a very brief answer. 11. 